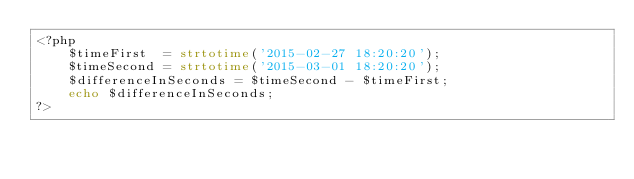Convert code to text. <code><loc_0><loc_0><loc_500><loc_500><_PHP_><?php
	$timeFirst  = strtotime('2015-02-27 18:20:20');
	$timeSecond = strtotime('2015-03-01 18:20:20');
	$differenceInSeconds = $timeSecond - $timeFirst;
	echo $differenceInSeconds;
?></code> 